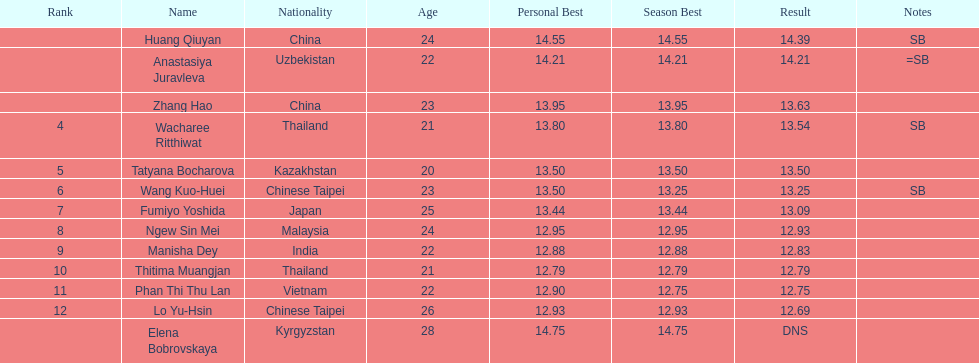Which country had the most competitors ranked in the top three in the event? China. 